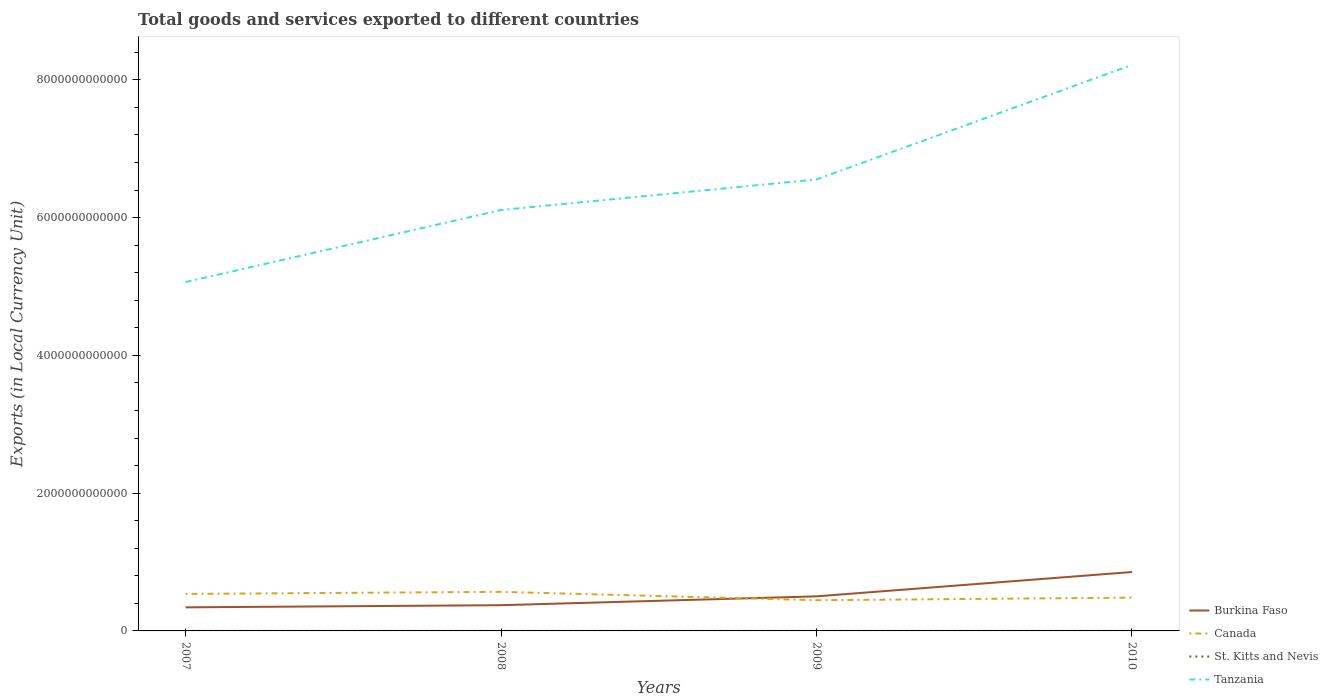Across all years, what is the maximum Amount of goods and services exports in Canada?
Your response must be concise. 4.46e+11. What is the total Amount of goods and services exports in Burkina Faso in the graph?
Your answer should be compact. -5.13e+11. What is the difference between the highest and the second highest Amount of goods and services exports in Canada?
Give a very brief answer. 1.22e+11. How many lines are there?
Offer a very short reply. 4. What is the difference between two consecutive major ticks on the Y-axis?
Offer a terse response. 2.00e+12. Are the values on the major ticks of Y-axis written in scientific E-notation?
Ensure brevity in your answer.  No. Does the graph contain any zero values?
Keep it short and to the point. No. Does the graph contain grids?
Your answer should be very brief. No. Where does the legend appear in the graph?
Make the answer very short. Bottom right. How are the legend labels stacked?
Your answer should be very brief. Vertical. What is the title of the graph?
Make the answer very short. Total goods and services exported to different countries. Does "Arab World" appear as one of the legend labels in the graph?
Offer a very short reply. No. What is the label or title of the X-axis?
Your answer should be very brief. Years. What is the label or title of the Y-axis?
Offer a terse response. Exports (in Local Currency Unit). What is the Exports (in Local Currency Unit) in Burkina Faso in 2007?
Your response must be concise. 3.42e+11. What is the Exports (in Local Currency Unit) of Canada in 2007?
Provide a short and direct response. 5.37e+11. What is the Exports (in Local Currency Unit) of St. Kitts and Nevis in 2007?
Make the answer very short. 6.29e+08. What is the Exports (in Local Currency Unit) in Tanzania in 2007?
Provide a succinct answer. 5.06e+12. What is the Exports (in Local Currency Unit) of Burkina Faso in 2008?
Provide a short and direct response. 3.74e+11. What is the Exports (in Local Currency Unit) of Canada in 2008?
Provide a succinct answer. 5.67e+11. What is the Exports (in Local Currency Unit) in St. Kitts and Nevis in 2008?
Keep it short and to the point. 6.36e+08. What is the Exports (in Local Currency Unit) in Tanzania in 2008?
Provide a succinct answer. 6.11e+12. What is the Exports (in Local Currency Unit) of Burkina Faso in 2009?
Keep it short and to the point. 5.02e+11. What is the Exports (in Local Currency Unit) in Canada in 2009?
Keep it short and to the point. 4.46e+11. What is the Exports (in Local Currency Unit) of St. Kitts and Nevis in 2009?
Keep it short and to the point. 4.77e+08. What is the Exports (in Local Currency Unit) in Tanzania in 2009?
Your answer should be compact. 6.55e+12. What is the Exports (in Local Currency Unit) in Burkina Faso in 2010?
Keep it short and to the point. 8.55e+11. What is the Exports (in Local Currency Unit) of Canada in 2010?
Offer a very short reply. 4.83e+11. What is the Exports (in Local Currency Unit) of St. Kitts and Nevis in 2010?
Your response must be concise. 5.73e+08. What is the Exports (in Local Currency Unit) of Tanzania in 2010?
Your response must be concise. 8.22e+12. Across all years, what is the maximum Exports (in Local Currency Unit) in Burkina Faso?
Provide a short and direct response. 8.55e+11. Across all years, what is the maximum Exports (in Local Currency Unit) in Canada?
Make the answer very short. 5.67e+11. Across all years, what is the maximum Exports (in Local Currency Unit) of St. Kitts and Nevis?
Provide a succinct answer. 6.36e+08. Across all years, what is the maximum Exports (in Local Currency Unit) of Tanzania?
Make the answer very short. 8.22e+12. Across all years, what is the minimum Exports (in Local Currency Unit) of Burkina Faso?
Provide a succinct answer. 3.42e+11. Across all years, what is the minimum Exports (in Local Currency Unit) in Canada?
Your response must be concise. 4.46e+11. Across all years, what is the minimum Exports (in Local Currency Unit) in St. Kitts and Nevis?
Provide a short and direct response. 4.77e+08. Across all years, what is the minimum Exports (in Local Currency Unit) in Tanzania?
Offer a very short reply. 5.06e+12. What is the total Exports (in Local Currency Unit) of Burkina Faso in the graph?
Your answer should be very brief. 2.07e+12. What is the total Exports (in Local Currency Unit) in Canada in the graph?
Ensure brevity in your answer.  2.03e+12. What is the total Exports (in Local Currency Unit) in St. Kitts and Nevis in the graph?
Provide a short and direct response. 2.31e+09. What is the total Exports (in Local Currency Unit) of Tanzania in the graph?
Offer a terse response. 2.59e+13. What is the difference between the Exports (in Local Currency Unit) in Burkina Faso in 2007 and that in 2008?
Offer a terse response. -3.12e+1. What is the difference between the Exports (in Local Currency Unit) of Canada in 2007 and that in 2008?
Provide a succinct answer. -2.99e+1. What is the difference between the Exports (in Local Currency Unit) in St. Kitts and Nevis in 2007 and that in 2008?
Keep it short and to the point. -6.53e+06. What is the difference between the Exports (in Local Currency Unit) of Tanzania in 2007 and that in 2008?
Your answer should be compact. -1.05e+12. What is the difference between the Exports (in Local Currency Unit) of Burkina Faso in 2007 and that in 2009?
Your answer should be very brief. -1.59e+11. What is the difference between the Exports (in Local Currency Unit) of Canada in 2007 and that in 2009?
Keep it short and to the point. 9.17e+1. What is the difference between the Exports (in Local Currency Unit) in St. Kitts and Nevis in 2007 and that in 2009?
Your answer should be very brief. 1.52e+08. What is the difference between the Exports (in Local Currency Unit) in Tanzania in 2007 and that in 2009?
Make the answer very short. -1.49e+12. What is the difference between the Exports (in Local Currency Unit) of Burkina Faso in 2007 and that in 2010?
Your answer should be very brief. -5.13e+11. What is the difference between the Exports (in Local Currency Unit) of Canada in 2007 and that in 2010?
Ensure brevity in your answer.  5.42e+1. What is the difference between the Exports (in Local Currency Unit) of St. Kitts and Nevis in 2007 and that in 2010?
Provide a succinct answer. 5.62e+07. What is the difference between the Exports (in Local Currency Unit) of Tanzania in 2007 and that in 2010?
Ensure brevity in your answer.  -3.15e+12. What is the difference between the Exports (in Local Currency Unit) in Burkina Faso in 2008 and that in 2009?
Provide a short and direct response. -1.28e+11. What is the difference between the Exports (in Local Currency Unit) of Canada in 2008 and that in 2009?
Make the answer very short. 1.22e+11. What is the difference between the Exports (in Local Currency Unit) in St. Kitts and Nevis in 2008 and that in 2009?
Offer a terse response. 1.59e+08. What is the difference between the Exports (in Local Currency Unit) in Tanzania in 2008 and that in 2009?
Give a very brief answer. -4.44e+11. What is the difference between the Exports (in Local Currency Unit) of Burkina Faso in 2008 and that in 2010?
Provide a succinct answer. -4.82e+11. What is the difference between the Exports (in Local Currency Unit) in Canada in 2008 and that in 2010?
Offer a terse response. 8.41e+1. What is the difference between the Exports (in Local Currency Unit) of St. Kitts and Nevis in 2008 and that in 2010?
Provide a short and direct response. 6.27e+07. What is the difference between the Exports (in Local Currency Unit) in Tanzania in 2008 and that in 2010?
Give a very brief answer. -2.11e+12. What is the difference between the Exports (in Local Currency Unit) of Burkina Faso in 2009 and that in 2010?
Provide a succinct answer. -3.53e+11. What is the difference between the Exports (in Local Currency Unit) in Canada in 2009 and that in 2010?
Offer a terse response. -3.75e+1. What is the difference between the Exports (in Local Currency Unit) of St. Kitts and Nevis in 2009 and that in 2010?
Make the answer very short. -9.62e+07. What is the difference between the Exports (in Local Currency Unit) in Tanzania in 2009 and that in 2010?
Offer a very short reply. -1.66e+12. What is the difference between the Exports (in Local Currency Unit) in Burkina Faso in 2007 and the Exports (in Local Currency Unit) in Canada in 2008?
Ensure brevity in your answer.  -2.25e+11. What is the difference between the Exports (in Local Currency Unit) of Burkina Faso in 2007 and the Exports (in Local Currency Unit) of St. Kitts and Nevis in 2008?
Your answer should be very brief. 3.42e+11. What is the difference between the Exports (in Local Currency Unit) in Burkina Faso in 2007 and the Exports (in Local Currency Unit) in Tanzania in 2008?
Keep it short and to the point. -5.77e+12. What is the difference between the Exports (in Local Currency Unit) of Canada in 2007 and the Exports (in Local Currency Unit) of St. Kitts and Nevis in 2008?
Your response must be concise. 5.37e+11. What is the difference between the Exports (in Local Currency Unit) of Canada in 2007 and the Exports (in Local Currency Unit) of Tanzania in 2008?
Keep it short and to the point. -5.57e+12. What is the difference between the Exports (in Local Currency Unit) of St. Kitts and Nevis in 2007 and the Exports (in Local Currency Unit) of Tanzania in 2008?
Provide a succinct answer. -6.11e+12. What is the difference between the Exports (in Local Currency Unit) in Burkina Faso in 2007 and the Exports (in Local Currency Unit) in Canada in 2009?
Give a very brief answer. -1.03e+11. What is the difference between the Exports (in Local Currency Unit) in Burkina Faso in 2007 and the Exports (in Local Currency Unit) in St. Kitts and Nevis in 2009?
Offer a terse response. 3.42e+11. What is the difference between the Exports (in Local Currency Unit) in Burkina Faso in 2007 and the Exports (in Local Currency Unit) in Tanzania in 2009?
Ensure brevity in your answer.  -6.21e+12. What is the difference between the Exports (in Local Currency Unit) in Canada in 2007 and the Exports (in Local Currency Unit) in St. Kitts and Nevis in 2009?
Give a very brief answer. 5.37e+11. What is the difference between the Exports (in Local Currency Unit) in Canada in 2007 and the Exports (in Local Currency Unit) in Tanzania in 2009?
Your answer should be very brief. -6.02e+12. What is the difference between the Exports (in Local Currency Unit) of St. Kitts and Nevis in 2007 and the Exports (in Local Currency Unit) of Tanzania in 2009?
Keep it short and to the point. -6.55e+12. What is the difference between the Exports (in Local Currency Unit) of Burkina Faso in 2007 and the Exports (in Local Currency Unit) of Canada in 2010?
Ensure brevity in your answer.  -1.41e+11. What is the difference between the Exports (in Local Currency Unit) of Burkina Faso in 2007 and the Exports (in Local Currency Unit) of St. Kitts and Nevis in 2010?
Ensure brevity in your answer.  3.42e+11. What is the difference between the Exports (in Local Currency Unit) of Burkina Faso in 2007 and the Exports (in Local Currency Unit) of Tanzania in 2010?
Offer a very short reply. -7.88e+12. What is the difference between the Exports (in Local Currency Unit) of Canada in 2007 and the Exports (in Local Currency Unit) of St. Kitts and Nevis in 2010?
Keep it short and to the point. 5.37e+11. What is the difference between the Exports (in Local Currency Unit) in Canada in 2007 and the Exports (in Local Currency Unit) in Tanzania in 2010?
Provide a succinct answer. -7.68e+12. What is the difference between the Exports (in Local Currency Unit) in St. Kitts and Nevis in 2007 and the Exports (in Local Currency Unit) in Tanzania in 2010?
Offer a terse response. -8.22e+12. What is the difference between the Exports (in Local Currency Unit) of Burkina Faso in 2008 and the Exports (in Local Currency Unit) of Canada in 2009?
Give a very brief answer. -7.21e+1. What is the difference between the Exports (in Local Currency Unit) of Burkina Faso in 2008 and the Exports (in Local Currency Unit) of St. Kitts and Nevis in 2009?
Provide a short and direct response. 3.73e+11. What is the difference between the Exports (in Local Currency Unit) of Burkina Faso in 2008 and the Exports (in Local Currency Unit) of Tanzania in 2009?
Your answer should be compact. -6.18e+12. What is the difference between the Exports (in Local Currency Unit) in Canada in 2008 and the Exports (in Local Currency Unit) in St. Kitts and Nevis in 2009?
Give a very brief answer. 5.67e+11. What is the difference between the Exports (in Local Currency Unit) in Canada in 2008 and the Exports (in Local Currency Unit) in Tanzania in 2009?
Keep it short and to the point. -5.99e+12. What is the difference between the Exports (in Local Currency Unit) of St. Kitts and Nevis in 2008 and the Exports (in Local Currency Unit) of Tanzania in 2009?
Your response must be concise. -6.55e+12. What is the difference between the Exports (in Local Currency Unit) of Burkina Faso in 2008 and the Exports (in Local Currency Unit) of Canada in 2010?
Keep it short and to the point. -1.10e+11. What is the difference between the Exports (in Local Currency Unit) in Burkina Faso in 2008 and the Exports (in Local Currency Unit) in St. Kitts and Nevis in 2010?
Your answer should be compact. 3.73e+11. What is the difference between the Exports (in Local Currency Unit) in Burkina Faso in 2008 and the Exports (in Local Currency Unit) in Tanzania in 2010?
Offer a terse response. -7.84e+12. What is the difference between the Exports (in Local Currency Unit) in Canada in 2008 and the Exports (in Local Currency Unit) in St. Kitts and Nevis in 2010?
Offer a very short reply. 5.67e+11. What is the difference between the Exports (in Local Currency Unit) of Canada in 2008 and the Exports (in Local Currency Unit) of Tanzania in 2010?
Offer a very short reply. -7.65e+12. What is the difference between the Exports (in Local Currency Unit) of St. Kitts and Nevis in 2008 and the Exports (in Local Currency Unit) of Tanzania in 2010?
Give a very brief answer. -8.22e+12. What is the difference between the Exports (in Local Currency Unit) in Burkina Faso in 2009 and the Exports (in Local Currency Unit) in Canada in 2010?
Make the answer very short. 1.86e+1. What is the difference between the Exports (in Local Currency Unit) in Burkina Faso in 2009 and the Exports (in Local Currency Unit) in St. Kitts and Nevis in 2010?
Ensure brevity in your answer.  5.01e+11. What is the difference between the Exports (in Local Currency Unit) of Burkina Faso in 2009 and the Exports (in Local Currency Unit) of Tanzania in 2010?
Keep it short and to the point. -7.72e+12. What is the difference between the Exports (in Local Currency Unit) in Canada in 2009 and the Exports (in Local Currency Unit) in St. Kitts and Nevis in 2010?
Offer a very short reply. 4.45e+11. What is the difference between the Exports (in Local Currency Unit) in Canada in 2009 and the Exports (in Local Currency Unit) in Tanzania in 2010?
Give a very brief answer. -7.77e+12. What is the difference between the Exports (in Local Currency Unit) of St. Kitts and Nevis in 2009 and the Exports (in Local Currency Unit) of Tanzania in 2010?
Provide a succinct answer. -8.22e+12. What is the average Exports (in Local Currency Unit) of Burkina Faso per year?
Keep it short and to the point. 5.18e+11. What is the average Exports (in Local Currency Unit) in Canada per year?
Ensure brevity in your answer.  5.08e+11. What is the average Exports (in Local Currency Unit) in St. Kitts and Nevis per year?
Provide a succinct answer. 5.79e+08. What is the average Exports (in Local Currency Unit) of Tanzania per year?
Offer a terse response. 6.49e+12. In the year 2007, what is the difference between the Exports (in Local Currency Unit) in Burkina Faso and Exports (in Local Currency Unit) in Canada?
Offer a very short reply. -1.95e+11. In the year 2007, what is the difference between the Exports (in Local Currency Unit) of Burkina Faso and Exports (in Local Currency Unit) of St. Kitts and Nevis?
Make the answer very short. 3.42e+11. In the year 2007, what is the difference between the Exports (in Local Currency Unit) of Burkina Faso and Exports (in Local Currency Unit) of Tanzania?
Offer a terse response. -4.72e+12. In the year 2007, what is the difference between the Exports (in Local Currency Unit) of Canada and Exports (in Local Currency Unit) of St. Kitts and Nevis?
Give a very brief answer. 5.37e+11. In the year 2007, what is the difference between the Exports (in Local Currency Unit) of Canada and Exports (in Local Currency Unit) of Tanzania?
Your response must be concise. -4.53e+12. In the year 2007, what is the difference between the Exports (in Local Currency Unit) in St. Kitts and Nevis and Exports (in Local Currency Unit) in Tanzania?
Provide a succinct answer. -5.06e+12. In the year 2008, what is the difference between the Exports (in Local Currency Unit) of Burkina Faso and Exports (in Local Currency Unit) of Canada?
Give a very brief answer. -1.94e+11. In the year 2008, what is the difference between the Exports (in Local Currency Unit) in Burkina Faso and Exports (in Local Currency Unit) in St. Kitts and Nevis?
Make the answer very short. 3.73e+11. In the year 2008, what is the difference between the Exports (in Local Currency Unit) of Burkina Faso and Exports (in Local Currency Unit) of Tanzania?
Give a very brief answer. -5.74e+12. In the year 2008, what is the difference between the Exports (in Local Currency Unit) in Canada and Exports (in Local Currency Unit) in St. Kitts and Nevis?
Your response must be concise. 5.67e+11. In the year 2008, what is the difference between the Exports (in Local Currency Unit) of Canada and Exports (in Local Currency Unit) of Tanzania?
Offer a very short reply. -5.54e+12. In the year 2008, what is the difference between the Exports (in Local Currency Unit) of St. Kitts and Nevis and Exports (in Local Currency Unit) of Tanzania?
Keep it short and to the point. -6.11e+12. In the year 2009, what is the difference between the Exports (in Local Currency Unit) of Burkina Faso and Exports (in Local Currency Unit) of Canada?
Give a very brief answer. 5.62e+1. In the year 2009, what is the difference between the Exports (in Local Currency Unit) of Burkina Faso and Exports (in Local Currency Unit) of St. Kitts and Nevis?
Provide a short and direct response. 5.01e+11. In the year 2009, what is the difference between the Exports (in Local Currency Unit) of Burkina Faso and Exports (in Local Currency Unit) of Tanzania?
Ensure brevity in your answer.  -6.05e+12. In the year 2009, what is the difference between the Exports (in Local Currency Unit) in Canada and Exports (in Local Currency Unit) in St. Kitts and Nevis?
Give a very brief answer. 4.45e+11. In the year 2009, what is the difference between the Exports (in Local Currency Unit) of Canada and Exports (in Local Currency Unit) of Tanzania?
Ensure brevity in your answer.  -6.11e+12. In the year 2009, what is the difference between the Exports (in Local Currency Unit) of St. Kitts and Nevis and Exports (in Local Currency Unit) of Tanzania?
Ensure brevity in your answer.  -6.55e+12. In the year 2010, what is the difference between the Exports (in Local Currency Unit) of Burkina Faso and Exports (in Local Currency Unit) of Canada?
Offer a very short reply. 3.72e+11. In the year 2010, what is the difference between the Exports (in Local Currency Unit) of Burkina Faso and Exports (in Local Currency Unit) of St. Kitts and Nevis?
Offer a very short reply. 8.55e+11. In the year 2010, what is the difference between the Exports (in Local Currency Unit) in Burkina Faso and Exports (in Local Currency Unit) in Tanzania?
Ensure brevity in your answer.  -7.36e+12. In the year 2010, what is the difference between the Exports (in Local Currency Unit) in Canada and Exports (in Local Currency Unit) in St. Kitts and Nevis?
Give a very brief answer. 4.83e+11. In the year 2010, what is the difference between the Exports (in Local Currency Unit) of Canada and Exports (in Local Currency Unit) of Tanzania?
Your answer should be compact. -7.73e+12. In the year 2010, what is the difference between the Exports (in Local Currency Unit) of St. Kitts and Nevis and Exports (in Local Currency Unit) of Tanzania?
Offer a very short reply. -8.22e+12. What is the ratio of the Exports (in Local Currency Unit) of Burkina Faso in 2007 to that in 2008?
Offer a very short reply. 0.92. What is the ratio of the Exports (in Local Currency Unit) in Canada in 2007 to that in 2008?
Make the answer very short. 0.95. What is the ratio of the Exports (in Local Currency Unit) of St. Kitts and Nevis in 2007 to that in 2008?
Offer a terse response. 0.99. What is the ratio of the Exports (in Local Currency Unit) of Tanzania in 2007 to that in 2008?
Give a very brief answer. 0.83. What is the ratio of the Exports (in Local Currency Unit) of Burkina Faso in 2007 to that in 2009?
Give a very brief answer. 0.68. What is the ratio of the Exports (in Local Currency Unit) in Canada in 2007 to that in 2009?
Offer a terse response. 1.21. What is the ratio of the Exports (in Local Currency Unit) of St. Kitts and Nevis in 2007 to that in 2009?
Offer a terse response. 1.32. What is the ratio of the Exports (in Local Currency Unit) in Tanzania in 2007 to that in 2009?
Your answer should be very brief. 0.77. What is the ratio of the Exports (in Local Currency Unit) of Burkina Faso in 2007 to that in 2010?
Provide a succinct answer. 0.4. What is the ratio of the Exports (in Local Currency Unit) in Canada in 2007 to that in 2010?
Keep it short and to the point. 1.11. What is the ratio of the Exports (in Local Currency Unit) of St. Kitts and Nevis in 2007 to that in 2010?
Offer a terse response. 1.1. What is the ratio of the Exports (in Local Currency Unit) in Tanzania in 2007 to that in 2010?
Offer a very short reply. 0.62. What is the ratio of the Exports (in Local Currency Unit) of Burkina Faso in 2008 to that in 2009?
Provide a succinct answer. 0.74. What is the ratio of the Exports (in Local Currency Unit) of Canada in 2008 to that in 2009?
Your answer should be very brief. 1.27. What is the ratio of the Exports (in Local Currency Unit) in St. Kitts and Nevis in 2008 to that in 2009?
Offer a terse response. 1.33. What is the ratio of the Exports (in Local Currency Unit) in Tanzania in 2008 to that in 2009?
Keep it short and to the point. 0.93. What is the ratio of the Exports (in Local Currency Unit) in Burkina Faso in 2008 to that in 2010?
Your answer should be very brief. 0.44. What is the ratio of the Exports (in Local Currency Unit) in Canada in 2008 to that in 2010?
Offer a very short reply. 1.17. What is the ratio of the Exports (in Local Currency Unit) in St. Kitts and Nevis in 2008 to that in 2010?
Keep it short and to the point. 1.11. What is the ratio of the Exports (in Local Currency Unit) of Tanzania in 2008 to that in 2010?
Offer a very short reply. 0.74. What is the ratio of the Exports (in Local Currency Unit) of Burkina Faso in 2009 to that in 2010?
Give a very brief answer. 0.59. What is the ratio of the Exports (in Local Currency Unit) in Canada in 2009 to that in 2010?
Your answer should be compact. 0.92. What is the ratio of the Exports (in Local Currency Unit) of St. Kitts and Nevis in 2009 to that in 2010?
Give a very brief answer. 0.83. What is the ratio of the Exports (in Local Currency Unit) of Tanzania in 2009 to that in 2010?
Your response must be concise. 0.8. What is the difference between the highest and the second highest Exports (in Local Currency Unit) of Burkina Faso?
Give a very brief answer. 3.53e+11. What is the difference between the highest and the second highest Exports (in Local Currency Unit) in Canada?
Your response must be concise. 2.99e+1. What is the difference between the highest and the second highest Exports (in Local Currency Unit) of St. Kitts and Nevis?
Make the answer very short. 6.53e+06. What is the difference between the highest and the second highest Exports (in Local Currency Unit) of Tanzania?
Keep it short and to the point. 1.66e+12. What is the difference between the highest and the lowest Exports (in Local Currency Unit) of Burkina Faso?
Make the answer very short. 5.13e+11. What is the difference between the highest and the lowest Exports (in Local Currency Unit) of Canada?
Make the answer very short. 1.22e+11. What is the difference between the highest and the lowest Exports (in Local Currency Unit) in St. Kitts and Nevis?
Provide a short and direct response. 1.59e+08. What is the difference between the highest and the lowest Exports (in Local Currency Unit) of Tanzania?
Offer a very short reply. 3.15e+12. 